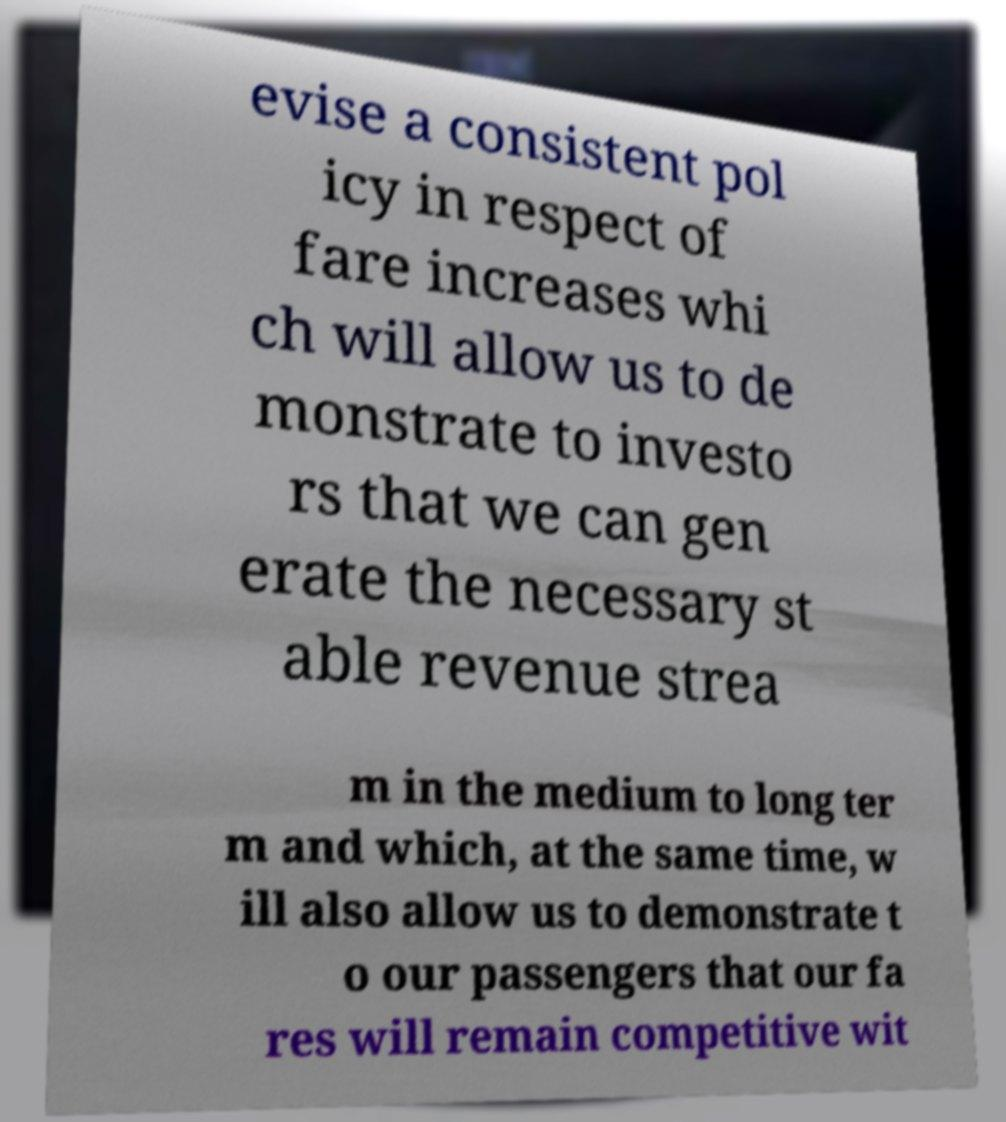Please read and relay the text visible in this image. What does it say? evise a consistent pol icy in respect of fare increases whi ch will allow us to de monstrate to investo rs that we can gen erate the necessary st able revenue strea m in the medium to long ter m and which, at the same time, w ill also allow us to demonstrate t o our passengers that our fa res will remain competitive wit 